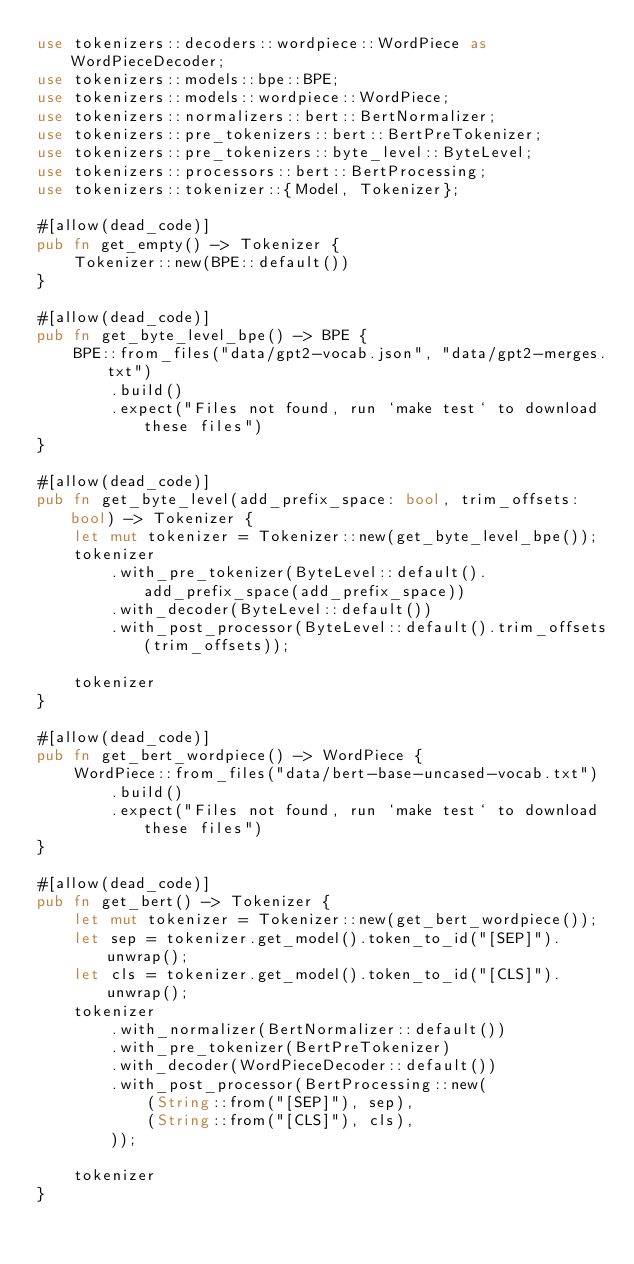Convert code to text. <code><loc_0><loc_0><loc_500><loc_500><_Rust_>use tokenizers::decoders::wordpiece::WordPiece as WordPieceDecoder;
use tokenizers::models::bpe::BPE;
use tokenizers::models::wordpiece::WordPiece;
use tokenizers::normalizers::bert::BertNormalizer;
use tokenizers::pre_tokenizers::bert::BertPreTokenizer;
use tokenizers::pre_tokenizers::byte_level::ByteLevel;
use tokenizers::processors::bert::BertProcessing;
use tokenizers::tokenizer::{Model, Tokenizer};

#[allow(dead_code)]
pub fn get_empty() -> Tokenizer {
    Tokenizer::new(BPE::default())
}

#[allow(dead_code)]
pub fn get_byte_level_bpe() -> BPE {
    BPE::from_files("data/gpt2-vocab.json", "data/gpt2-merges.txt")
        .build()
        .expect("Files not found, run `make test` to download these files")
}

#[allow(dead_code)]
pub fn get_byte_level(add_prefix_space: bool, trim_offsets: bool) -> Tokenizer {
    let mut tokenizer = Tokenizer::new(get_byte_level_bpe());
    tokenizer
        .with_pre_tokenizer(ByteLevel::default().add_prefix_space(add_prefix_space))
        .with_decoder(ByteLevel::default())
        .with_post_processor(ByteLevel::default().trim_offsets(trim_offsets));

    tokenizer
}

#[allow(dead_code)]
pub fn get_bert_wordpiece() -> WordPiece {
    WordPiece::from_files("data/bert-base-uncased-vocab.txt")
        .build()
        .expect("Files not found, run `make test` to download these files")
}

#[allow(dead_code)]
pub fn get_bert() -> Tokenizer {
    let mut tokenizer = Tokenizer::new(get_bert_wordpiece());
    let sep = tokenizer.get_model().token_to_id("[SEP]").unwrap();
    let cls = tokenizer.get_model().token_to_id("[CLS]").unwrap();
    tokenizer
        .with_normalizer(BertNormalizer::default())
        .with_pre_tokenizer(BertPreTokenizer)
        .with_decoder(WordPieceDecoder::default())
        .with_post_processor(BertProcessing::new(
            (String::from("[SEP]"), sep),
            (String::from("[CLS]"), cls),
        ));

    tokenizer
}
</code> 